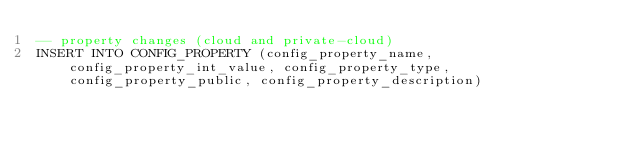Convert code to text. <code><loc_0><loc_0><loc_500><loc_500><_SQL_>-- property changes (cloud and private-cloud)
INSERT INTO CONFIG_PROPERTY (config_property_name, config_property_int_value, config_property_type, config_property_public, config_property_description)</code> 